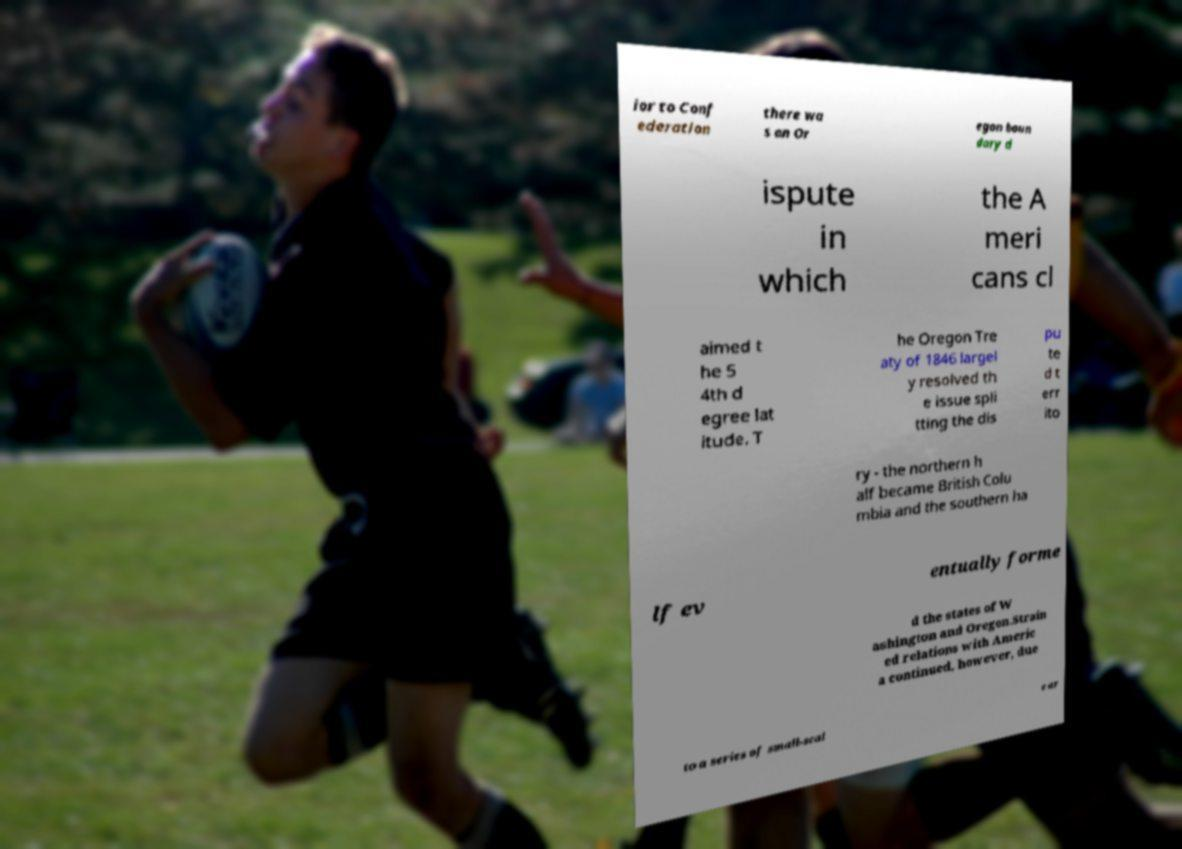Please read and relay the text visible in this image. What does it say? ior to Conf ederation there wa s an Or egon boun dary d ispute in which the A meri cans cl aimed t he 5 4th d egree lat itude. T he Oregon Tre aty of 1846 largel y resolved th e issue spli tting the dis pu te d t err ito ry - the northern h alf became British Colu mbia and the southern ha lf ev entually forme d the states of W ashington and Oregon.Strain ed relations with Americ a continued, however, due to a series of small-scal e ar 